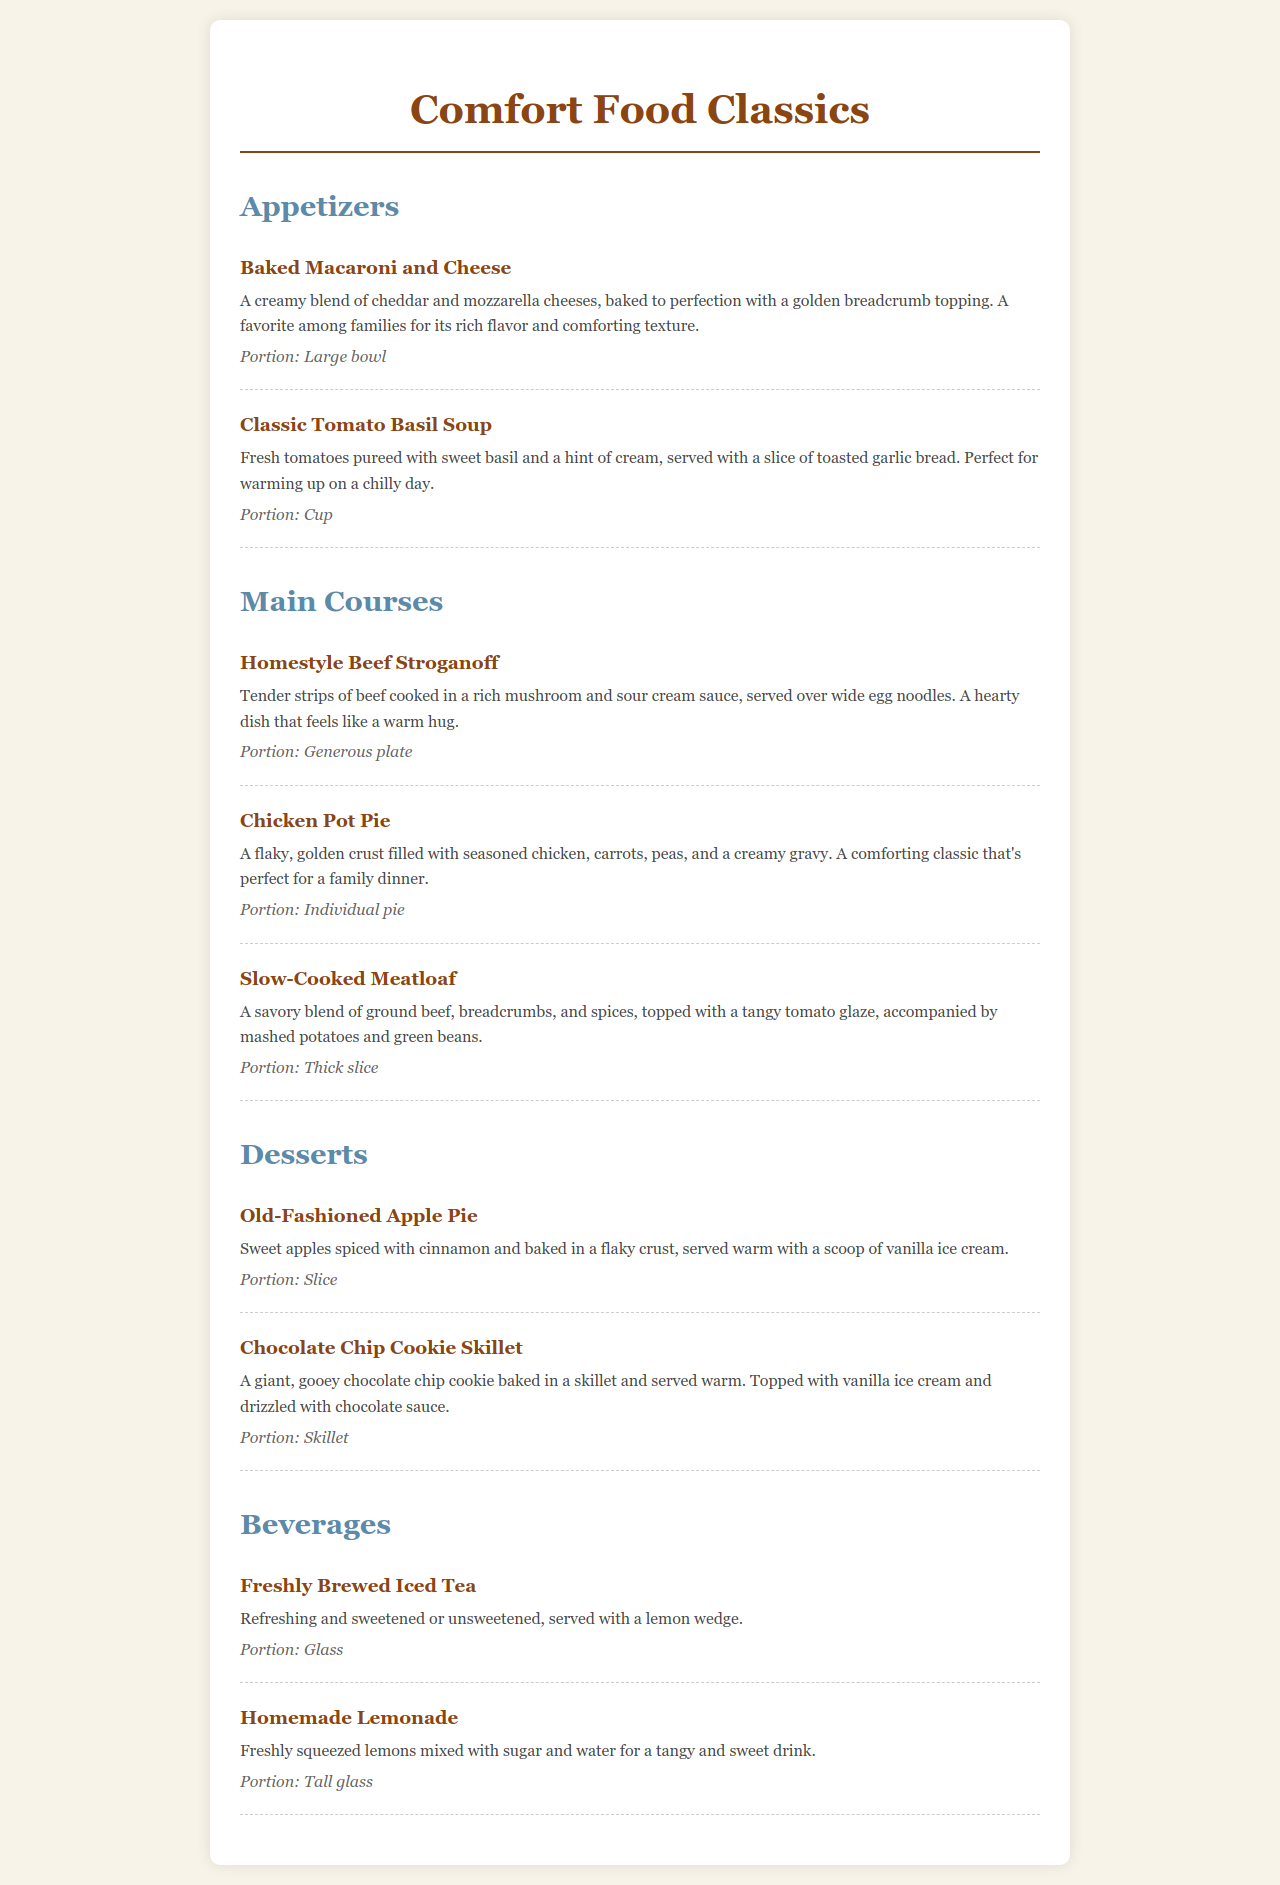What is the first appetizer listed on the menu? The first appetizer mentioned is Baked Macaroni and Cheese.
Answer: Baked Macaroni and Cheese How is the Classic Tomato Basil Soup served? The soup is served with a slice of toasted garlic bread.
Answer: With a slice of toasted garlic bread What type of dish is Chicken Pot Pie classified as? Chicken Pot Pie is classified as a main course.
Answer: Main course What dessert is served warm with a scoop of vanilla ice cream? The Old-Fashioned Apple Pie is served warm with a scoop of vanilla ice cream.
Answer: Old-Fashioned Apple Pie What is the portion size of the Slow-Cooked Meatloaf? The portion size is described as a thick slice.
Answer: Thick slice Which beverage is freshly brewed according to the menu? The menu states that the Freshly Brewed Iced Tea is a freshly brewed option.
Answer: Freshly Brewed Iced Tea What type of crust does the Chicken Pot Pie have? The Chicken Pot Pie has a flaky, golden crust.
Answer: Flaky, golden crust How many types of desserts are listed on the menu? There are two desserts listed: Old-Fashioned Apple Pie and Chocolate Chip Cookie Skillet.
Answer: Two What is the main ingredient of the Chocolate Chip Cookie Skillet? The main ingredient is a giant, gooey chocolate chip cookie.
Answer: Giant, gooey chocolate chip cookie 